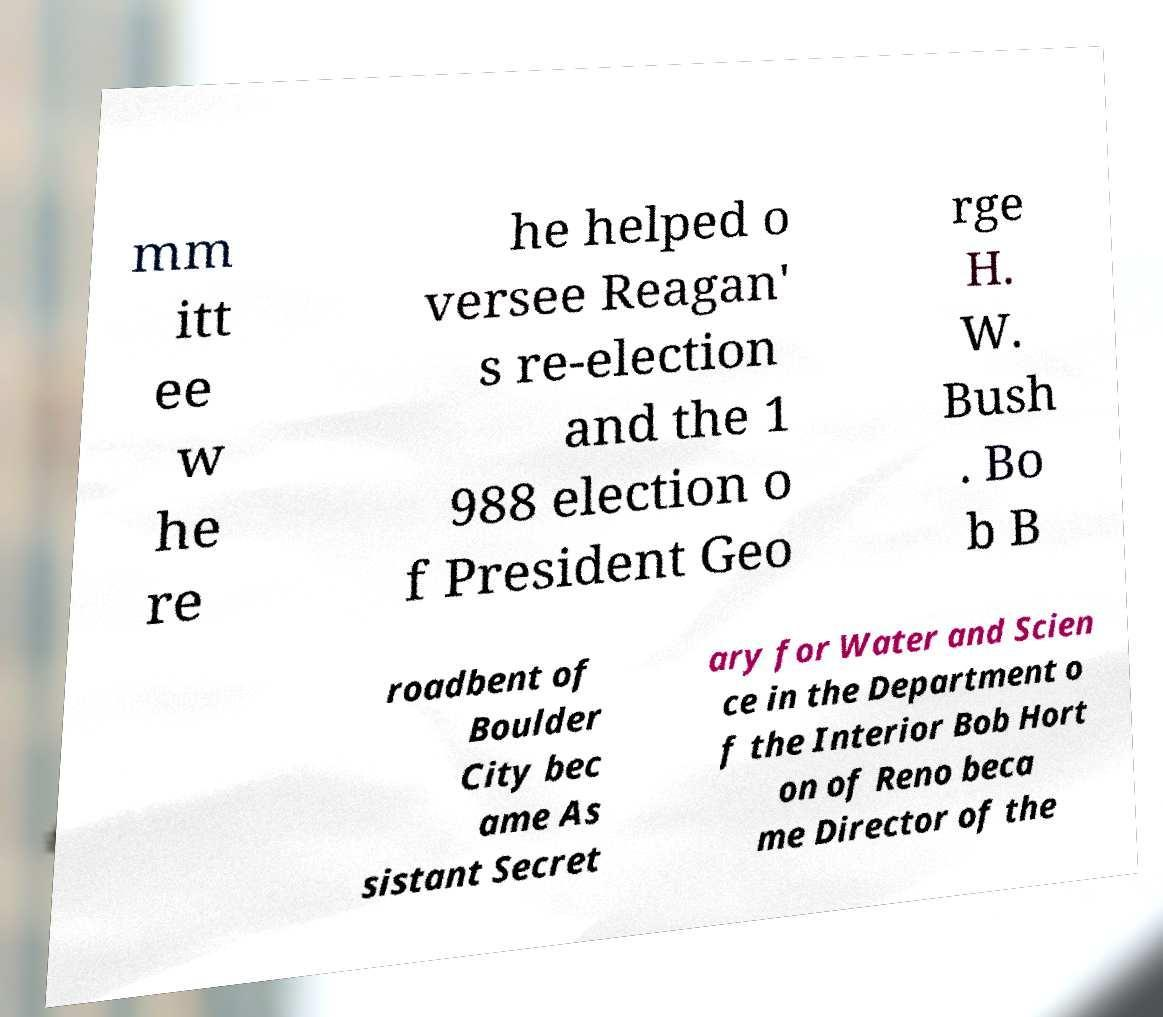Can you accurately transcribe the text from the provided image for me? mm itt ee w he re he helped o versee Reagan' s re-election and the 1 988 election o f President Geo rge H. W. Bush . Bo b B roadbent of Boulder City bec ame As sistant Secret ary for Water and Scien ce in the Department o f the Interior Bob Hort on of Reno beca me Director of the 